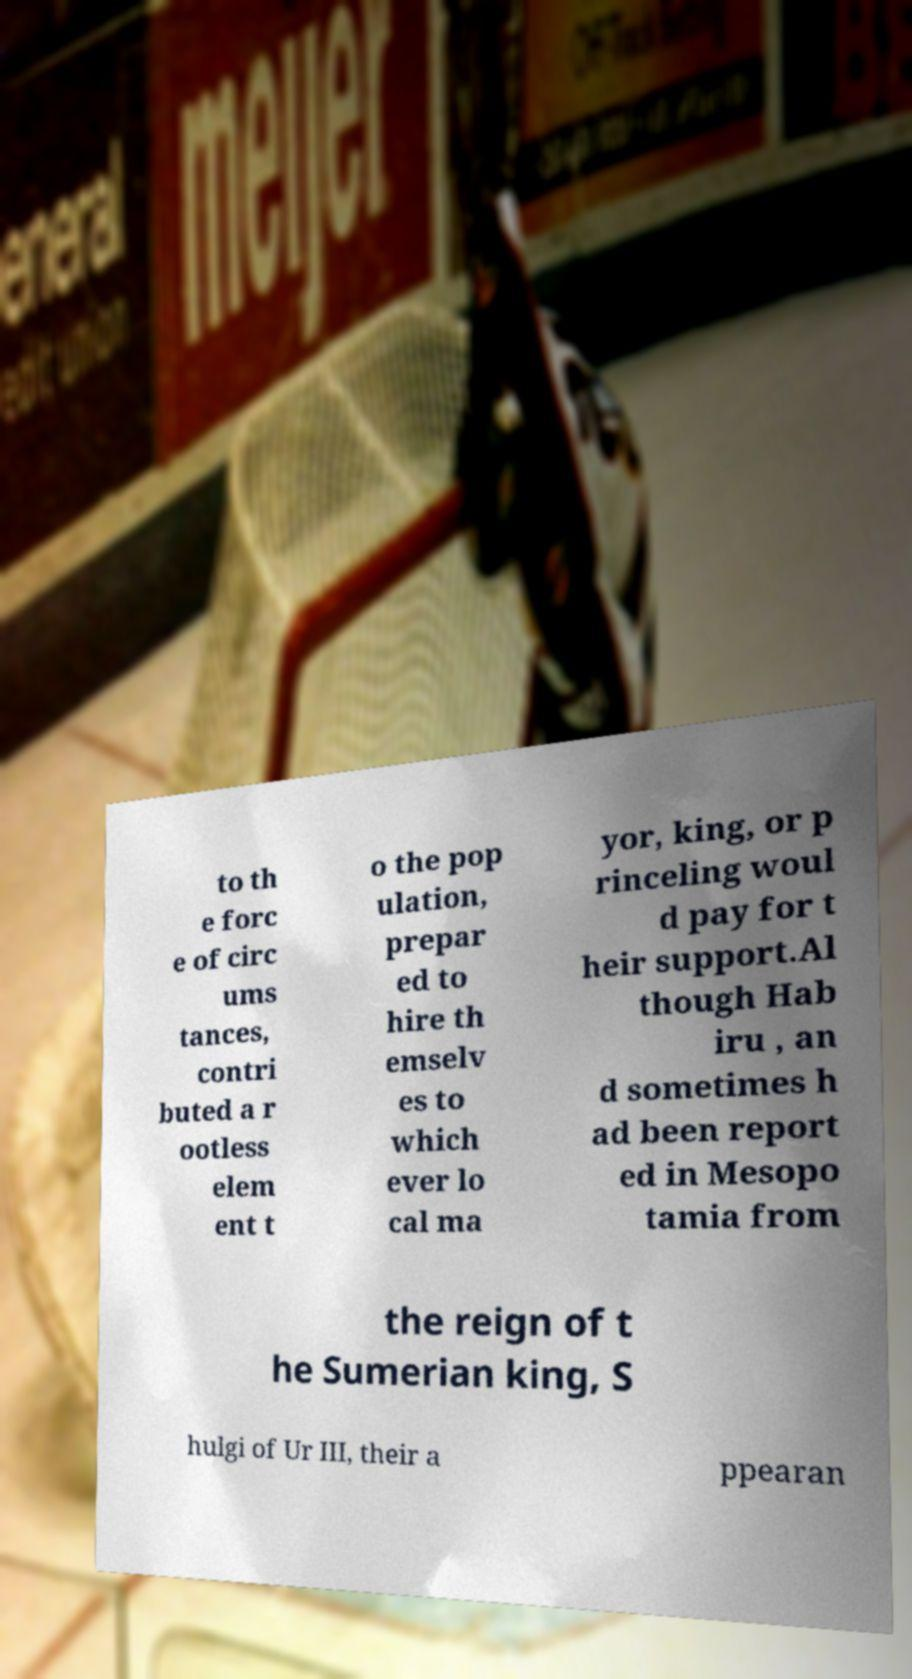Can you read and provide the text displayed in the image?This photo seems to have some interesting text. Can you extract and type it out for me? to th e forc e of circ ums tances, contri buted a r ootless elem ent t o the pop ulation, prepar ed to hire th emselv es to which ever lo cal ma yor, king, or p rinceling woul d pay for t heir support.Al though Hab iru , an d sometimes h ad been report ed in Mesopo tamia from the reign of t he Sumerian king, S hulgi of Ur III, their a ppearan 